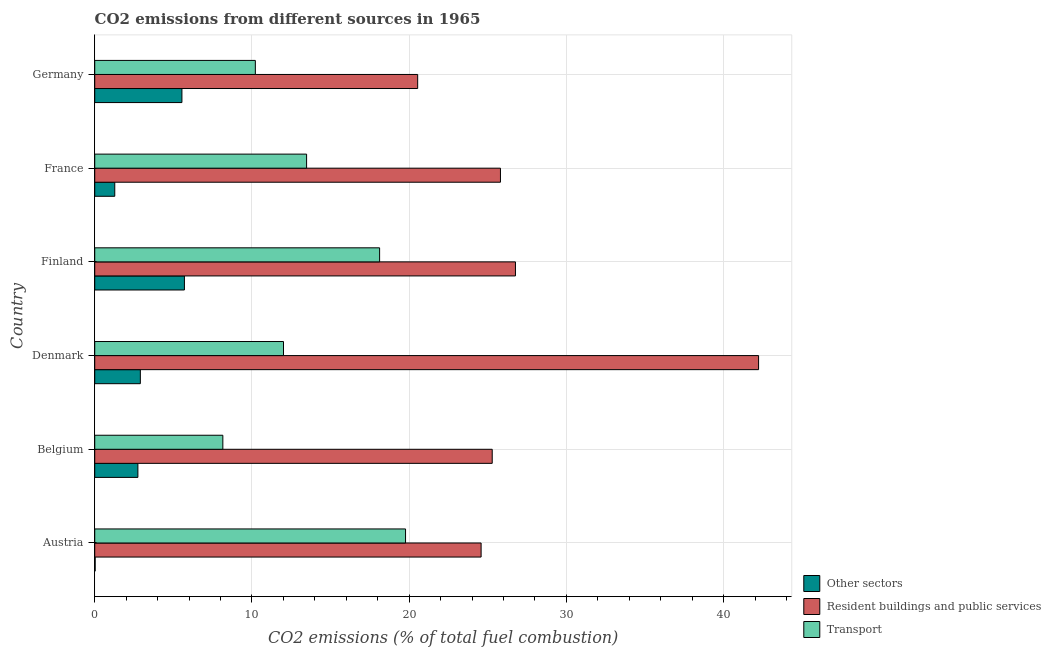How many different coloured bars are there?
Offer a very short reply. 3. Are the number of bars per tick equal to the number of legend labels?
Give a very brief answer. Yes. What is the percentage of co2 emissions from transport in France?
Provide a succinct answer. 13.48. Across all countries, what is the maximum percentage of co2 emissions from other sectors?
Offer a terse response. 5.7. Across all countries, what is the minimum percentage of co2 emissions from resident buildings and public services?
Your response must be concise. 20.54. What is the total percentage of co2 emissions from transport in the graph?
Provide a short and direct response. 81.74. What is the difference between the percentage of co2 emissions from other sectors in Austria and that in Belgium?
Ensure brevity in your answer.  -2.72. What is the difference between the percentage of co2 emissions from transport in Germany and the percentage of co2 emissions from resident buildings and public services in Denmark?
Your answer should be very brief. -32.01. What is the average percentage of co2 emissions from transport per country?
Your answer should be compact. 13.62. What is the difference between the percentage of co2 emissions from other sectors and percentage of co2 emissions from resident buildings and public services in France?
Your answer should be compact. -24.53. In how many countries, is the percentage of co2 emissions from transport greater than 34 %?
Keep it short and to the point. 0. What is the ratio of the percentage of co2 emissions from resident buildings and public services in Finland to that in Germany?
Give a very brief answer. 1.3. Is the difference between the percentage of co2 emissions from transport in Belgium and Finland greater than the difference between the percentage of co2 emissions from other sectors in Belgium and Finland?
Give a very brief answer. No. What is the difference between the highest and the second highest percentage of co2 emissions from other sectors?
Give a very brief answer. 0.16. What is the difference between the highest and the lowest percentage of co2 emissions from resident buildings and public services?
Give a very brief answer. 21.68. What does the 1st bar from the top in Denmark represents?
Your answer should be compact. Transport. What does the 3rd bar from the bottom in Denmark represents?
Offer a terse response. Transport. Is it the case that in every country, the sum of the percentage of co2 emissions from other sectors and percentage of co2 emissions from resident buildings and public services is greater than the percentage of co2 emissions from transport?
Keep it short and to the point. Yes. How many countries are there in the graph?
Make the answer very short. 6. Does the graph contain grids?
Your response must be concise. Yes. Where does the legend appear in the graph?
Keep it short and to the point. Bottom right. How many legend labels are there?
Make the answer very short. 3. How are the legend labels stacked?
Provide a succinct answer. Vertical. What is the title of the graph?
Your answer should be compact. CO2 emissions from different sources in 1965. What is the label or title of the X-axis?
Ensure brevity in your answer.  CO2 emissions (% of total fuel combustion). What is the label or title of the Y-axis?
Make the answer very short. Country. What is the CO2 emissions (% of total fuel combustion) of Other sectors in Austria?
Provide a succinct answer. 0.03. What is the CO2 emissions (% of total fuel combustion) of Resident buildings and public services in Austria?
Offer a very short reply. 24.58. What is the CO2 emissions (% of total fuel combustion) of Transport in Austria?
Make the answer very short. 19.77. What is the CO2 emissions (% of total fuel combustion) in Other sectors in Belgium?
Make the answer very short. 2.75. What is the CO2 emissions (% of total fuel combustion) of Resident buildings and public services in Belgium?
Provide a short and direct response. 25.28. What is the CO2 emissions (% of total fuel combustion) of Transport in Belgium?
Offer a very short reply. 8.15. What is the CO2 emissions (% of total fuel combustion) of Other sectors in Denmark?
Offer a terse response. 2.9. What is the CO2 emissions (% of total fuel combustion) in Resident buildings and public services in Denmark?
Your answer should be very brief. 42.23. What is the CO2 emissions (% of total fuel combustion) of Transport in Denmark?
Your response must be concise. 12.01. What is the CO2 emissions (% of total fuel combustion) of Other sectors in Finland?
Offer a terse response. 5.7. What is the CO2 emissions (% of total fuel combustion) of Resident buildings and public services in Finland?
Ensure brevity in your answer.  26.76. What is the CO2 emissions (% of total fuel combustion) of Transport in Finland?
Offer a terse response. 18.12. What is the CO2 emissions (% of total fuel combustion) of Other sectors in France?
Make the answer very short. 1.27. What is the CO2 emissions (% of total fuel combustion) in Resident buildings and public services in France?
Ensure brevity in your answer.  25.81. What is the CO2 emissions (% of total fuel combustion) of Transport in France?
Make the answer very short. 13.48. What is the CO2 emissions (% of total fuel combustion) in Other sectors in Germany?
Make the answer very short. 5.55. What is the CO2 emissions (% of total fuel combustion) in Resident buildings and public services in Germany?
Offer a terse response. 20.54. What is the CO2 emissions (% of total fuel combustion) of Transport in Germany?
Keep it short and to the point. 10.22. Across all countries, what is the maximum CO2 emissions (% of total fuel combustion) of Other sectors?
Your answer should be very brief. 5.7. Across all countries, what is the maximum CO2 emissions (% of total fuel combustion) in Resident buildings and public services?
Provide a short and direct response. 42.23. Across all countries, what is the maximum CO2 emissions (% of total fuel combustion) of Transport?
Your response must be concise. 19.77. Across all countries, what is the minimum CO2 emissions (% of total fuel combustion) in Other sectors?
Give a very brief answer. 0.03. Across all countries, what is the minimum CO2 emissions (% of total fuel combustion) of Resident buildings and public services?
Offer a terse response. 20.54. Across all countries, what is the minimum CO2 emissions (% of total fuel combustion) in Transport?
Your response must be concise. 8.15. What is the total CO2 emissions (% of total fuel combustion) of Other sectors in the graph?
Provide a succinct answer. 18.2. What is the total CO2 emissions (% of total fuel combustion) of Resident buildings and public services in the graph?
Offer a very short reply. 165.2. What is the total CO2 emissions (% of total fuel combustion) of Transport in the graph?
Your answer should be compact. 81.74. What is the difference between the CO2 emissions (% of total fuel combustion) in Other sectors in Austria and that in Belgium?
Keep it short and to the point. -2.72. What is the difference between the CO2 emissions (% of total fuel combustion) in Resident buildings and public services in Austria and that in Belgium?
Ensure brevity in your answer.  -0.71. What is the difference between the CO2 emissions (% of total fuel combustion) of Transport in Austria and that in Belgium?
Your answer should be very brief. 11.62. What is the difference between the CO2 emissions (% of total fuel combustion) of Other sectors in Austria and that in Denmark?
Keep it short and to the point. -2.87. What is the difference between the CO2 emissions (% of total fuel combustion) of Resident buildings and public services in Austria and that in Denmark?
Offer a terse response. -17.65. What is the difference between the CO2 emissions (% of total fuel combustion) of Transport in Austria and that in Denmark?
Your answer should be very brief. 7.76. What is the difference between the CO2 emissions (% of total fuel combustion) of Other sectors in Austria and that in Finland?
Your answer should be compact. -5.68. What is the difference between the CO2 emissions (% of total fuel combustion) in Resident buildings and public services in Austria and that in Finland?
Provide a short and direct response. -2.19. What is the difference between the CO2 emissions (% of total fuel combustion) in Transport in Austria and that in Finland?
Ensure brevity in your answer.  1.65. What is the difference between the CO2 emissions (% of total fuel combustion) of Other sectors in Austria and that in France?
Make the answer very short. -1.25. What is the difference between the CO2 emissions (% of total fuel combustion) of Resident buildings and public services in Austria and that in France?
Keep it short and to the point. -1.23. What is the difference between the CO2 emissions (% of total fuel combustion) in Transport in Austria and that in France?
Provide a succinct answer. 6.29. What is the difference between the CO2 emissions (% of total fuel combustion) of Other sectors in Austria and that in Germany?
Provide a succinct answer. -5.52. What is the difference between the CO2 emissions (% of total fuel combustion) of Resident buildings and public services in Austria and that in Germany?
Offer a terse response. 4.03. What is the difference between the CO2 emissions (% of total fuel combustion) in Transport in Austria and that in Germany?
Offer a terse response. 9.55. What is the difference between the CO2 emissions (% of total fuel combustion) in Other sectors in Belgium and that in Denmark?
Keep it short and to the point. -0.16. What is the difference between the CO2 emissions (% of total fuel combustion) in Resident buildings and public services in Belgium and that in Denmark?
Offer a terse response. -16.94. What is the difference between the CO2 emissions (% of total fuel combustion) of Transport in Belgium and that in Denmark?
Keep it short and to the point. -3.86. What is the difference between the CO2 emissions (% of total fuel combustion) of Other sectors in Belgium and that in Finland?
Offer a terse response. -2.96. What is the difference between the CO2 emissions (% of total fuel combustion) in Resident buildings and public services in Belgium and that in Finland?
Provide a succinct answer. -1.48. What is the difference between the CO2 emissions (% of total fuel combustion) in Transport in Belgium and that in Finland?
Give a very brief answer. -9.97. What is the difference between the CO2 emissions (% of total fuel combustion) in Other sectors in Belgium and that in France?
Give a very brief answer. 1.47. What is the difference between the CO2 emissions (% of total fuel combustion) in Resident buildings and public services in Belgium and that in France?
Give a very brief answer. -0.52. What is the difference between the CO2 emissions (% of total fuel combustion) in Transport in Belgium and that in France?
Your answer should be very brief. -5.33. What is the difference between the CO2 emissions (% of total fuel combustion) of Other sectors in Belgium and that in Germany?
Make the answer very short. -2.8. What is the difference between the CO2 emissions (% of total fuel combustion) in Resident buildings and public services in Belgium and that in Germany?
Offer a very short reply. 4.74. What is the difference between the CO2 emissions (% of total fuel combustion) of Transport in Belgium and that in Germany?
Keep it short and to the point. -2.07. What is the difference between the CO2 emissions (% of total fuel combustion) in Other sectors in Denmark and that in Finland?
Keep it short and to the point. -2.8. What is the difference between the CO2 emissions (% of total fuel combustion) in Resident buildings and public services in Denmark and that in Finland?
Offer a terse response. 15.47. What is the difference between the CO2 emissions (% of total fuel combustion) in Transport in Denmark and that in Finland?
Your answer should be compact. -6.11. What is the difference between the CO2 emissions (% of total fuel combustion) of Other sectors in Denmark and that in France?
Provide a short and direct response. 1.63. What is the difference between the CO2 emissions (% of total fuel combustion) in Resident buildings and public services in Denmark and that in France?
Your answer should be compact. 16.42. What is the difference between the CO2 emissions (% of total fuel combustion) in Transport in Denmark and that in France?
Offer a terse response. -1.47. What is the difference between the CO2 emissions (% of total fuel combustion) of Other sectors in Denmark and that in Germany?
Ensure brevity in your answer.  -2.64. What is the difference between the CO2 emissions (% of total fuel combustion) of Resident buildings and public services in Denmark and that in Germany?
Your response must be concise. 21.68. What is the difference between the CO2 emissions (% of total fuel combustion) of Transport in Denmark and that in Germany?
Offer a very short reply. 1.79. What is the difference between the CO2 emissions (% of total fuel combustion) in Other sectors in Finland and that in France?
Give a very brief answer. 4.43. What is the difference between the CO2 emissions (% of total fuel combustion) of Resident buildings and public services in Finland and that in France?
Make the answer very short. 0.95. What is the difference between the CO2 emissions (% of total fuel combustion) of Transport in Finland and that in France?
Make the answer very short. 4.64. What is the difference between the CO2 emissions (% of total fuel combustion) of Other sectors in Finland and that in Germany?
Ensure brevity in your answer.  0.16. What is the difference between the CO2 emissions (% of total fuel combustion) of Resident buildings and public services in Finland and that in Germany?
Provide a short and direct response. 6.22. What is the difference between the CO2 emissions (% of total fuel combustion) in Transport in Finland and that in Germany?
Offer a terse response. 7.9. What is the difference between the CO2 emissions (% of total fuel combustion) in Other sectors in France and that in Germany?
Your answer should be compact. -4.27. What is the difference between the CO2 emissions (% of total fuel combustion) of Resident buildings and public services in France and that in Germany?
Your answer should be very brief. 5.27. What is the difference between the CO2 emissions (% of total fuel combustion) in Transport in France and that in Germany?
Your answer should be compact. 3.26. What is the difference between the CO2 emissions (% of total fuel combustion) of Other sectors in Austria and the CO2 emissions (% of total fuel combustion) of Resident buildings and public services in Belgium?
Provide a short and direct response. -25.26. What is the difference between the CO2 emissions (% of total fuel combustion) of Other sectors in Austria and the CO2 emissions (% of total fuel combustion) of Transport in Belgium?
Offer a terse response. -8.12. What is the difference between the CO2 emissions (% of total fuel combustion) of Resident buildings and public services in Austria and the CO2 emissions (% of total fuel combustion) of Transport in Belgium?
Provide a short and direct response. 16.43. What is the difference between the CO2 emissions (% of total fuel combustion) of Other sectors in Austria and the CO2 emissions (% of total fuel combustion) of Resident buildings and public services in Denmark?
Make the answer very short. -42.2. What is the difference between the CO2 emissions (% of total fuel combustion) of Other sectors in Austria and the CO2 emissions (% of total fuel combustion) of Transport in Denmark?
Offer a very short reply. -11.98. What is the difference between the CO2 emissions (% of total fuel combustion) of Resident buildings and public services in Austria and the CO2 emissions (% of total fuel combustion) of Transport in Denmark?
Offer a very short reply. 12.57. What is the difference between the CO2 emissions (% of total fuel combustion) in Other sectors in Austria and the CO2 emissions (% of total fuel combustion) in Resident buildings and public services in Finland?
Offer a terse response. -26.73. What is the difference between the CO2 emissions (% of total fuel combustion) in Other sectors in Austria and the CO2 emissions (% of total fuel combustion) in Transport in Finland?
Keep it short and to the point. -18.09. What is the difference between the CO2 emissions (% of total fuel combustion) in Resident buildings and public services in Austria and the CO2 emissions (% of total fuel combustion) in Transport in Finland?
Your answer should be very brief. 6.46. What is the difference between the CO2 emissions (% of total fuel combustion) of Other sectors in Austria and the CO2 emissions (% of total fuel combustion) of Resident buildings and public services in France?
Give a very brief answer. -25.78. What is the difference between the CO2 emissions (% of total fuel combustion) in Other sectors in Austria and the CO2 emissions (% of total fuel combustion) in Transport in France?
Your answer should be very brief. -13.45. What is the difference between the CO2 emissions (% of total fuel combustion) in Resident buildings and public services in Austria and the CO2 emissions (% of total fuel combustion) in Transport in France?
Offer a terse response. 11.1. What is the difference between the CO2 emissions (% of total fuel combustion) of Other sectors in Austria and the CO2 emissions (% of total fuel combustion) of Resident buildings and public services in Germany?
Offer a terse response. -20.51. What is the difference between the CO2 emissions (% of total fuel combustion) in Other sectors in Austria and the CO2 emissions (% of total fuel combustion) in Transport in Germany?
Offer a very short reply. -10.19. What is the difference between the CO2 emissions (% of total fuel combustion) of Resident buildings and public services in Austria and the CO2 emissions (% of total fuel combustion) of Transport in Germany?
Your answer should be very brief. 14.36. What is the difference between the CO2 emissions (% of total fuel combustion) of Other sectors in Belgium and the CO2 emissions (% of total fuel combustion) of Resident buildings and public services in Denmark?
Offer a terse response. -39.48. What is the difference between the CO2 emissions (% of total fuel combustion) in Other sectors in Belgium and the CO2 emissions (% of total fuel combustion) in Transport in Denmark?
Your answer should be very brief. -9.26. What is the difference between the CO2 emissions (% of total fuel combustion) of Resident buildings and public services in Belgium and the CO2 emissions (% of total fuel combustion) of Transport in Denmark?
Keep it short and to the point. 13.28. What is the difference between the CO2 emissions (% of total fuel combustion) of Other sectors in Belgium and the CO2 emissions (% of total fuel combustion) of Resident buildings and public services in Finland?
Your answer should be very brief. -24.02. What is the difference between the CO2 emissions (% of total fuel combustion) in Other sectors in Belgium and the CO2 emissions (% of total fuel combustion) in Transport in Finland?
Provide a succinct answer. -15.38. What is the difference between the CO2 emissions (% of total fuel combustion) of Resident buildings and public services in Belgium and the CO2 emissions (% of total fuel combustion) of Transport in Finland?
Make the answer very short. 7.16. What is the difference between the CO2 emissions (% of total fuel combustion) in Other sectors in Belgium and the CO2 emissions (% of total fuel combustion) in Resident buildings and public services in France?
Offer a terse response. -23.06. What is the difference between the CO2 emissions (% of total fuel combustion) in Other sectors in Belgium and the CO2 emissions (% of total fuel combustion) in Transport in France?
Offer a very short reply. -10.73. What is the difference between the CO2 emissions (% of total fuel combustion) in Resident buildings and public services in Belgium and the CO2 emissions (% of total fuel combustion) in Transport in France?
Keep it short and to the point. 11.81. What is the difference between the CO2 emissions (% of total fuel combustion) in Other sectors in Belgium and the CO2 emissions (% of total fuel combustion) in Resident buildings and public services in Germany?
Make the answer very short. -17.8. What is the difference between the CO2 emissions (% of total fuel combustion) in Other sectors in Belgium and the CO2 emissions (% of total fuel combustion) in Transport in Germany?
Your answer should be compact. -7.47. What is the difference between the CO2 emissions (% of total fuel combustion) in Resident buildings and public services in Belgium and the CO2 emissions (% of total fuel combustion) in Transport in Germany?
Offer a very short reply. 15.07. What is the difference between the CO2 emissions (% of total fuel combustion) of Other sectors in Denmark and the CO2 emissions (% of total fuel combustion) of Resident buildings and public services in Finland?
Make the answer very short. -23.86. What is the difference between the CO2 emissions (% of total fuel combustion) of Other sectors in Denmark and the CO2 emissions (% of total fuel combustion) of Transport in Finland?
Offer a very short reply. -15.22. What is the difference between the CO2 emissions (% of total fuel combustion) in Resident buildings and public services in Denmark and the CO2 emissions (% of total fuel combustion) in Transport in Finland?
Your answer should be compact. 24.11. What is the difference between the CO2 emissions (% of total fuel combustion) in Other sectors in Denmark and the CO2 emissions (% of total fuel combustion) in Resident buildings and public services in France?
Ensure brevity in your answer.  -22.91. What is the difference between the CO2 emissions (% of total fuel combustion) of Other sectors in Denmark and the CO2 emissions (% of total fuel combustion) of Transport in France?
Keep it short and to the point. -10.57. What is the difference between the CO2 emissions (% of total fuel combustion) in Resident buildings and public services in Denmark and the CO2 emissions (% of total fuel combustion) in Transport in France?
Provide a short and direct response. 28.75. What is the difference between the CO2 emissions (% of total fuel combustion) of Other sectors in Denmark and the CO2 emissions (% of total fuel combustion) of Resident buildings and public services in Germany?
Keep it short and to the point. -17.64. What is the difference between the CO2 emissions (% of total fuel combustion) in Other sectors in Denmark and the CO2 emissions (% of total fuel combustion) in Transport in Germany?
Make the answer very short. -7.31. What is the difference between the CO2 emissions (% of total fuel combustion) of Resident buildings and public services in Denmark and the CO2 emissions (% of total fuel combustion) of Transport in Germany?
Provide a short and direct response. 32.01. What is the difference between the CO2 emissions (% of total fuel combustion) of Other sectors in Finland and the CO2 emissions (% of total fuel combustion) of Resident buildings and public services in France?
Your answer should be compact. -20.1. What is the difference between the CO2 emissions (% of total fuel combustion) of Other sectors in Finland and the CO2 emissions (% of total fuel combustion) of Transport in France?
Your response must be concise. -7.77. What is the difference between the CO2 emissions (% of total fuel combustion) in Resident buildings and public services in Finland and the CO2 emissions (% of total fuel combustion) in Transport in France?
Keep it short and to the point. 13.29. What is the difference between the CO2 emissions (% of total fuel combustion) in Other sectors in Finland and the CO2 emissions (% of total fuel combustion) in Resident buildings and public services in Germany?
Ensure brevity in your answer.  -14.84. What is the difference between the CO2 emissions (% of total fuel combustion) in Other sectors in Finland and the CO2 emissions (% of total fuel combustion) in Transport in Germany?
Your response must be concise. -4.51. What is the difference between the CO2 emissions (% of total fuel combustion) in Resident buildings and public services in Finland and the CO2 emissions (% of total fuel combustion) in Transport in Germany?
Give a very brief answer. 16.55. What is the difference between the CO2 emissions (% of total fuel combustion) in Other sectors in France and the CO2 emissions (% of total fuel combustion) in Resident buildings and public services in Germany?
Offer a very short reply. -19.27. What is the difference between the CO2 emissions (% of total fuel combustion) of Other sectors in France and the CO2 emissions (% of total fuel combustion) of Transport in Germany?
Offer a very short reply. -8.94. What is the difference between the CO2 emissions (% of total fuel combustion) of Resident buildings and public services in France and the CO2 emissions (% of total fuel combustion) of Transport in Germany?
Make the answer very short. 15.59. What is the average CO2 emissions (% of total fuel combustion) in Other sectors per country?
Your response must be concise. 3.03. What is the average CO2 emissions (% of total fuel combustion) of Resident buildings and public services per country?
Your answer should be very brief. 27.53. What is the average CO2 emissions (% of total fuel combustion) of Transport per country?
Your answer should be compact. 13.62. What is the difference between the CO2 emissions (% of total fuel combustion) of Other sectors and CO2 emissions (% of total fuel combustion) of Resident buildings and public services in Austria?
Ensure brevity in your answer.  -24.55. What is the difference between the CO2 emissions (% of total fuel combustion) of Other sectors and CO2 emissions (% of total fuel combustion) of Transport in Austria?
Provide a succinct answer. -19.74. What is the difference between the CO2 emissions (% of total fuel combustion) in Resident buildings and public services and CO2 emissions (% of total fuel combustion) in Transport in Austria?
Keep it short and to the point. 4.81. What is the difference between the CO2 emissions (% of total fuel combustion) of Other sectors and CO2 emissions (% of total fuel combustion) of Resident buildings and public services in Belgium?
Provide a succinct answer. -22.54. What is the difference between the CO2 emissions (% of total fuel combustion) of Other sectors and CO2 emissions (% of total fuel combustion) of Transport in Belgium?
Make the answer very short. -5.4. What is the difference between the CO2 emissions (% of total fuel combustion) in Resident buildings and public services and CO2 emissions (% of total fuel combustion) in Transport in Belgium?
Ensure brevity in your answer.  17.14. What is the difference between the CO2 emissions (% of total fuel combustion) in Other sectors and CO2 emissions (% of total fuel combustion) in Resident buildings and public services in Denmark?
Offer a terse response. -39.33. What is the difference between the CO2 emissions (% of total fuel combustion) in Other sectors and CO2 emissions (% of total fuel combustion) in Transport in Denmark?
Ensure brevity in your answer.  -9.11. What is the difference between the CO2 emissions (% of total fuel combustion) of Resident buildings and public services and CO2 emissions (% of total fuel combustion) of Transport in Denmark?
Your answer should be compact. 30.22. What is the difference between the CO2 emissions (% of total fuel combustion) of Other sectors and CO2 emissions (% of total fuel combustion) of Resident buildings and public services in Finland?
Your answer should be compact. -21.06. What is the difference between the CO2 emissions (% of total fuel combustion) of Other sectors and CO2 emissions (% of total fuel combustion) of Transport in Finland?
Keep it short and to the point. -12.42. What is the difference between the CO2 emissions (% of total fuel combustion) of Resident buildings and public services and CO2 emissions (% of total fuel combustion) of Transport in Finland?
Provide a short and direct response. 8.64. What is the difference between the CO2 emissions (% of total fuel combustion) in Other sectors and CO2 emissions (% of total fuel combustion) in Resident buildings and public services in France?
Provide a short and direct response. -24.53. What is the difference between the CO2 emissions (% of total fuel combustion) of Other sectors and CO2 emissions (% of total fuel combustion) of Transport in France?
Keep it short and to the point. -12.2. What is the difference between the CO2 emissions (% of total fuel combustion) of Resident buildings and public services and CO2 emissions (% of total fuel combustion) of Transport in France?
Offer a very short reply. 12.33. What is the difference between the CO2 emissions (% of total fuel combustion) of Other sectors and CO2 emissions (% of total fuel combustion) of Resident buildings and public services in Germany?
Keep it short and to the point. -15. What is the difference between the CO2 emissions (% of total fuel combustion) in Other sectors and CO2 emissions (% of total fuel combustion) in Transport in Germany?
Make the answer very short. -4.67. What is the difference between the CO2 emissions (% of total fuel combustion) of Resident buildings and public services and CO2 emissions (% of total fuel combustion) of Transport in Germany?
Give a very brief answer. 10.33. What is the ratio of the CO2 emissions (% of total fuel combustion) in Other sectors in Austria to that in Belgium?
Your answer should be compact. 0.01. What is the ratio of the CO2 emissions (% of total fuel combustion) in Resident buildings and public services in Austria to that in Belgium?
Keep it short and to the point. 0.97. What is the ratio of the CO2 emissions (% of total fuel combustion) in Transport in Austria to that in Belgium?
Keep it short and to the point. 2.43. What is the ratio of the CO2 emissions (% of total fuel combustion) in Other sectors in Austria to that in Denmark?
Give a very brief answer. 0.01. What is the ratio of the CO2 emissions (% of total fuel combustion) in Resident buildings and public services in Austria to that in Denmark?
Your answer should be compact. 0.58. What is the ratio of the CO2 emissions (% of total fuel combustion) in Transport in Austria to that in Denmark?
Ensure brevity in your answer.  1.65. What is the ratio of the CO2 emissions (% of total fuel combustion) of Other sectors in Austria to that in Finland?
Your response must be concise. 0. What is the ratio of the CO2 emissions (% of total fuel combustion) of Resident buildings and public services in Austria to that in Finland?
Provide a succinct answer. 0.92. What is the ratio of the CO2 emissions (% of total fuel combustion) of Transport in Austria to that in Finland?
Offer a terse response. 1.09. What is the ratio of the CO2 emissions (% of total fuel combustion) in Other sectors in Austria to that in France?
Your answer should be compact. 0.02. What is the ratio of the CO2 emissions (% of total fuel combustion) in Resident buildings and public services in Austria to that in France?
Offer a terse response. 0.95. What is the ratio of the CO2 emissions (% of total fuel combustion) of Transport in Austria to that in France?
Give a very brief answer. 1.47. What is the ratio of the CO2 emissions (% of total fuel combustion) in Other sectors in Austria to that in Germany?
Make the answer very short. 0. What is the ratio of the CO2 emissions (% of total fuel combustion) of Resident buildings and public services in Austria to that in Germany?
Keep it short and to the point. 1.2. What is the ratio of the CO2 emissions (% of total fuel combustion) in Transport in Austria to that in Germany?
Make the answer very short. 1.94. What is the ratio of the CO2 emissions (% of total fuel combustion) of Other sectors in Belgium to that in Denmark?
Offer a terse response. 0.95. What is the ratio of the CO2 emissions (% of total fuel combustion) of Resident buildings and public services in Belgium to that in Denmark?
Make the answer very short. 0.6. What is the ratio of the CO2 emissions (% of total fuel combustion) in Transport in Belgium to that in Denmark?
Your response must be concise. 0.68. What is the ratio of the CO2 emissions (% of total fuel combustion) in Other sectors in Belgium to that in Finland?
Ensure brevity in your answer.  0.48. What is the ratio of the CO2 emissions (% of total fuel combustion) in Resident buildings and public services in Belgium to that in Finland?
Make the answer very short. 0.94. What is the ratio of the CO2 emissions (% of total fuel combustion) of Transport in Belgium to that in Finland?
Provide a short and direct response. 0.45. What is the ratio of the CO2 emissions (% of total fuel combustion) of Other sectors in Belgium to that in France?
Make the answer very short. 2.15. What is the ratio of the CO2 emissions (% of total fuel combustion) in Resident buildings and public services in Belgium to that in France?
Provide a succinct answer. 0.98. What is the ratio of the CO2 emissions (% of total fuel combustion) in Transport in Belgium to that in France?
Your answer should be compact. 0.6. What is the ratio of the CO2 emissions (% of total fuel combustion) in Other sectors in Belgium to that in Germany?
Your answer should be very brief. 0.49. What is the ratio of the CO2 emissions (% of total fuel combustion) of Resident buildings and public services in Belgium to that in Germany?
Your answer should be compact. 1.23. What is the ratio of the CO2 emissions (% of total fuel combustion) of Transport in Belgium to that in Germany?
Provide a succinct answer. 0.8. What is the ratio of the CO2 emissions (% of total fuel combustion) in Other sectors in Denmark to that in Finland?
Make the answer very short. 0.51. What is the ratio of the CO2 emissions (% of total fuel combustion) in Resident buildings and public services in Denmark to that in Finland?
Make the answer very short. 1.58. What is the ratio of the CO2 emissions (% of total fuel combustion) of Transport in Denmark to that in Finland?
Ensure brevity in your answer.  0.66. What is the ratio of the CO2 emissions (% of total fuel combustion) of Other sectors in Denmark to that in France?
Your answer should be compact. 2.28. What is the ratio of the CO2 emissions (% of total fuel combustion) of Resident buildings and public services in Denmark to that in France?
Your answer should be very brief. 1.64. What is the ratio of the CO2 emissions (% of total fuel combustion) in Transport in Denmark to that in France?
Your answer should be very brief. 0.89. What is the ratio of the CO2 emissions (% of total fuel combustion) of Other sectors in Denmark to that in Germany?
Keep it short and to the point. 0.52. What is the ratio of the CO2 emissions (% of total fuel combustion) of Resident buildings and public services in Denmark to that in Germany?
Offer a very short reply. 2.06. What is the ratio of the CO2 emissions (% of total fuel combustion) in Transport in Denmark to that in Germany?
Give a very brief answer. 1.18. What is the ratio of the CO2 emissions (% of total fuel combustion) of Other sectors in Finland to that in France?
Ensure brevity in your answer.  4.48. What is the ratio of the CO2 emissions (% of total fuel combustion) of Transport in Finland to that in France?
Your response must be concise. 1.34. What is the ratio of the CO2 emissions (% of total fuel combustion) in Other sectors in Finland to that in Germany?
Make the answer very short. 1.03. What is the ratio of the CO2 emissions (% of total fuel combustion) in Resident buildings and public services in Finland to that in Germany?
Offer a terse response. 1.3. What is the ratio of the CO2 emissions (% of total fuel combustion) in Transport in Finland to that in Germany?
Offer a terse response. 1.77. What is the ratio of the CO2 emissions (% of total fuel combustion) of Other sectors in France to that in Germany?
Ensure brevity in your answer.  0.23. What is the ratio of the CO2 emissions (% of total fuel combustion) of Resident buildings and public services in France to that in Germany?
Give a very brief answer. 1.26. What is the ratio of the CO2 emissions (% of total fuel combustion) in Transport in France to that in Germany?
Your response must be concise. 1.32. What is the difference between the highest and the second highest CO2 emissions (% of total fuel combustion) in Other sectors?
Provide a succinct answer. 0.16. What is the difference between the highest and the second highest CO2 emissions (% of total fuel combustion) of Resident buildings and public services?
Offer a very short reply. 15.47. What is the difference between the highest and the second highest CO2 emissions (% of total fuel combustion) in Transport?
Your answer should be very brief. 1.65. What is the difference between the highest and the lowest CO2 emissions (% of total fuel combustion) in Other sectors?
Offer a very short reply. 5.68. What is the difference between the highest and the lowest CO2 emissions (% of total fuel combustion) in Resident buildings and public services?
Offer a terse response. 21.68. What is the difference between the highest and the lowest CO2 emissions (% of total fuel combustion) in Transport?
Your answer should be compact. 11.62. 